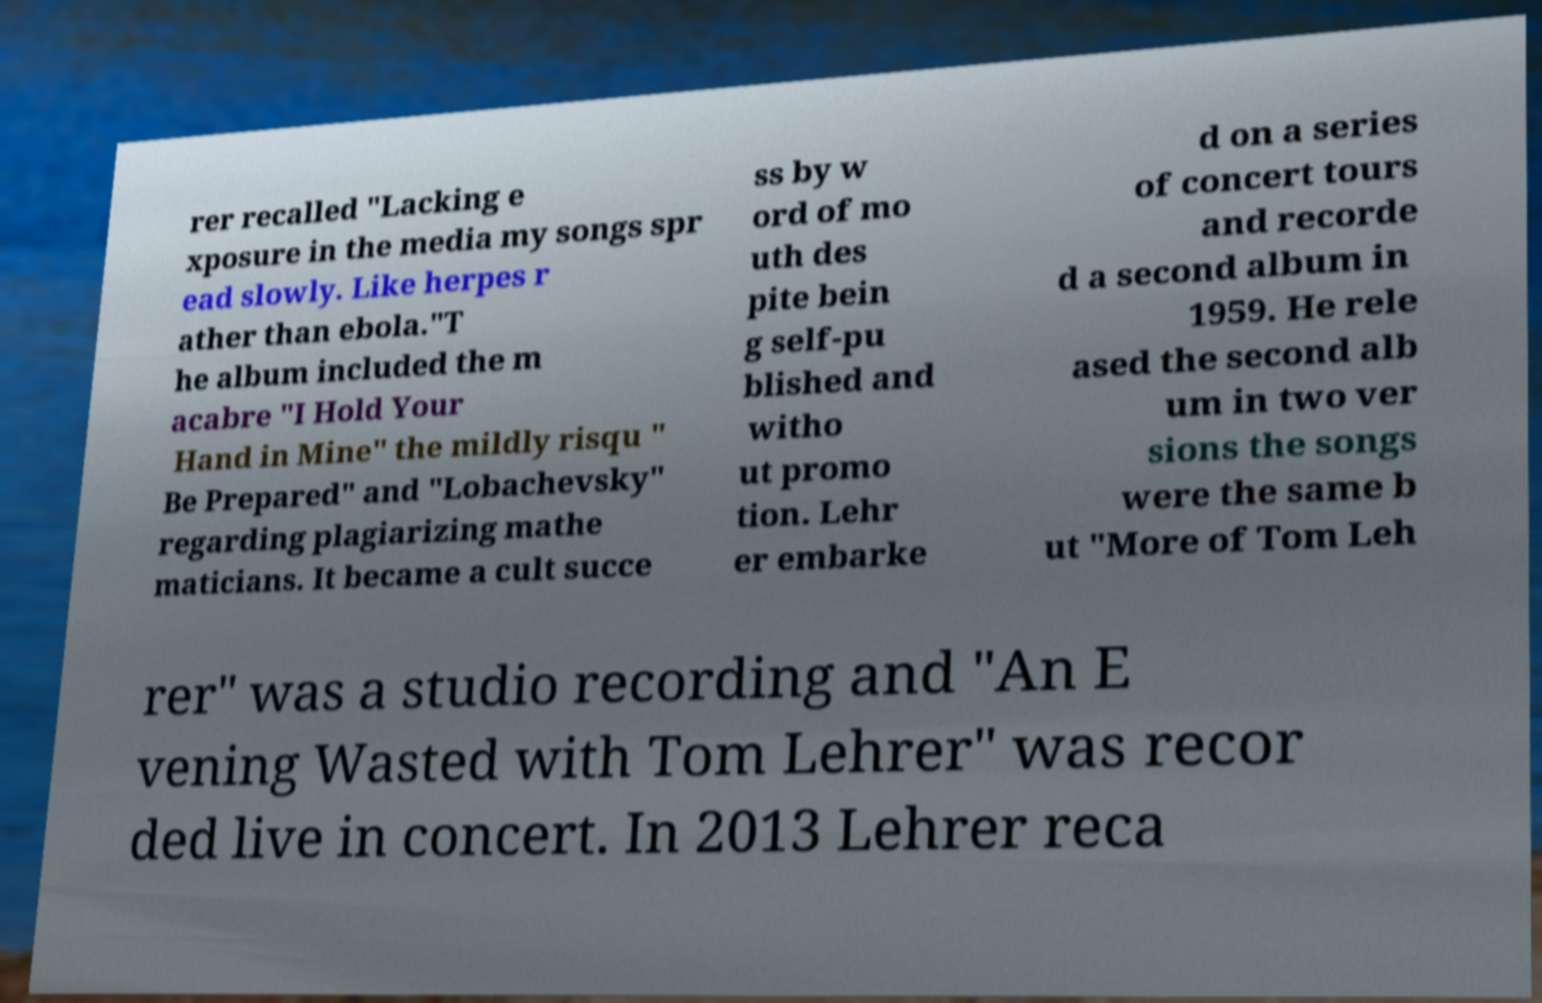I need the written content from this picture converted into text. Can you do that? rer recalled "Lacking e xposure in the media my songs spr ead slowly. Like herpes r ather than ebola."T he album included the m acabre "I Hold Your Hand in Mine" the mildly risqu " Be Prepared" and "Lobachevsky" regarding plagiarizing mathe maticians. It became a cult succe ss by w ord of mo uth des pite bein g self-pu blished and witho ut promo tion. Lehr er embarke d on a series of concert tours and recorde d a second album in 1959. He rele ased the second alb um in two ver sions the songs were the same b ut "More of Tom Leh rer" was a studio recording and "An E vening Wasted with Tom Lehrer" was recor ded live in concert. In 2013 Lehrer reca 